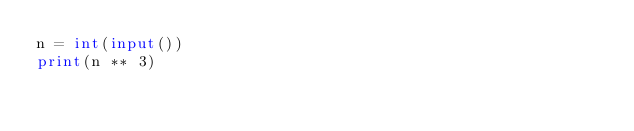Convert code to text. <code><loc_0><loc_0><loc_500><loc_500><_Python_>n = int(input())
print(n ** 3)</code> 